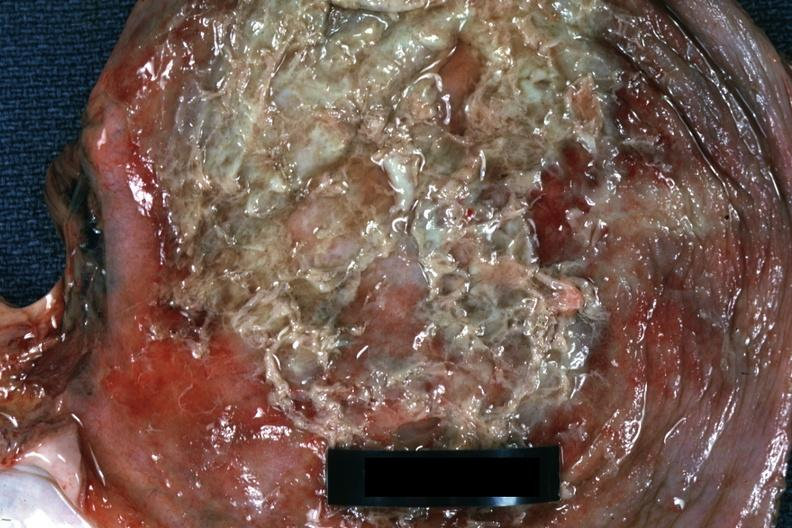what does this image show?
Answer the question using a single word or phrase. Close-up view of purulent exudate over diaphragm very good 